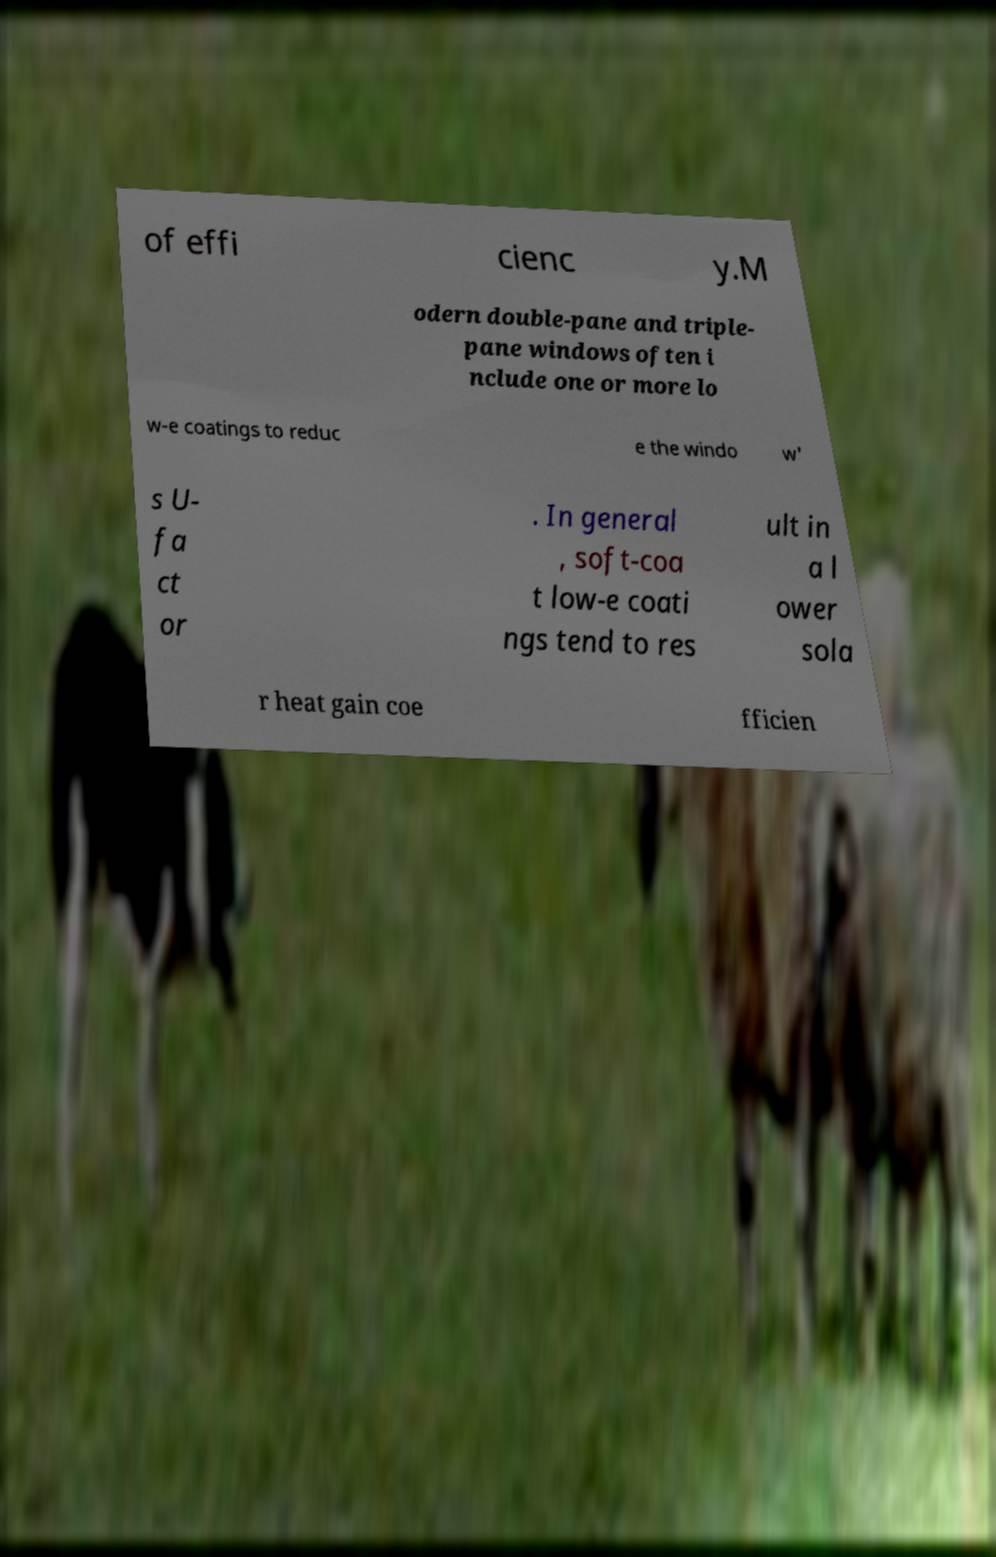I need the written content from this picture converted into text. Can you do that? of effi cienc y.M odern double-pane and triple- pane windows often i nclude one or more lo w-e coatings to reduc e the windo w' s U- fa ct or . In general , soft-coa t low-e coati ngs tend to res ult in a l ower sola r heat gain coe fficien 